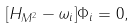Convert formula to latex. <formula><loc_0><loc_0><loc_500><loc_500>[ H _ { M ^ { 2 } } - \omega _ { i } ] \Phi _ { i } = 0 ,</formula> 